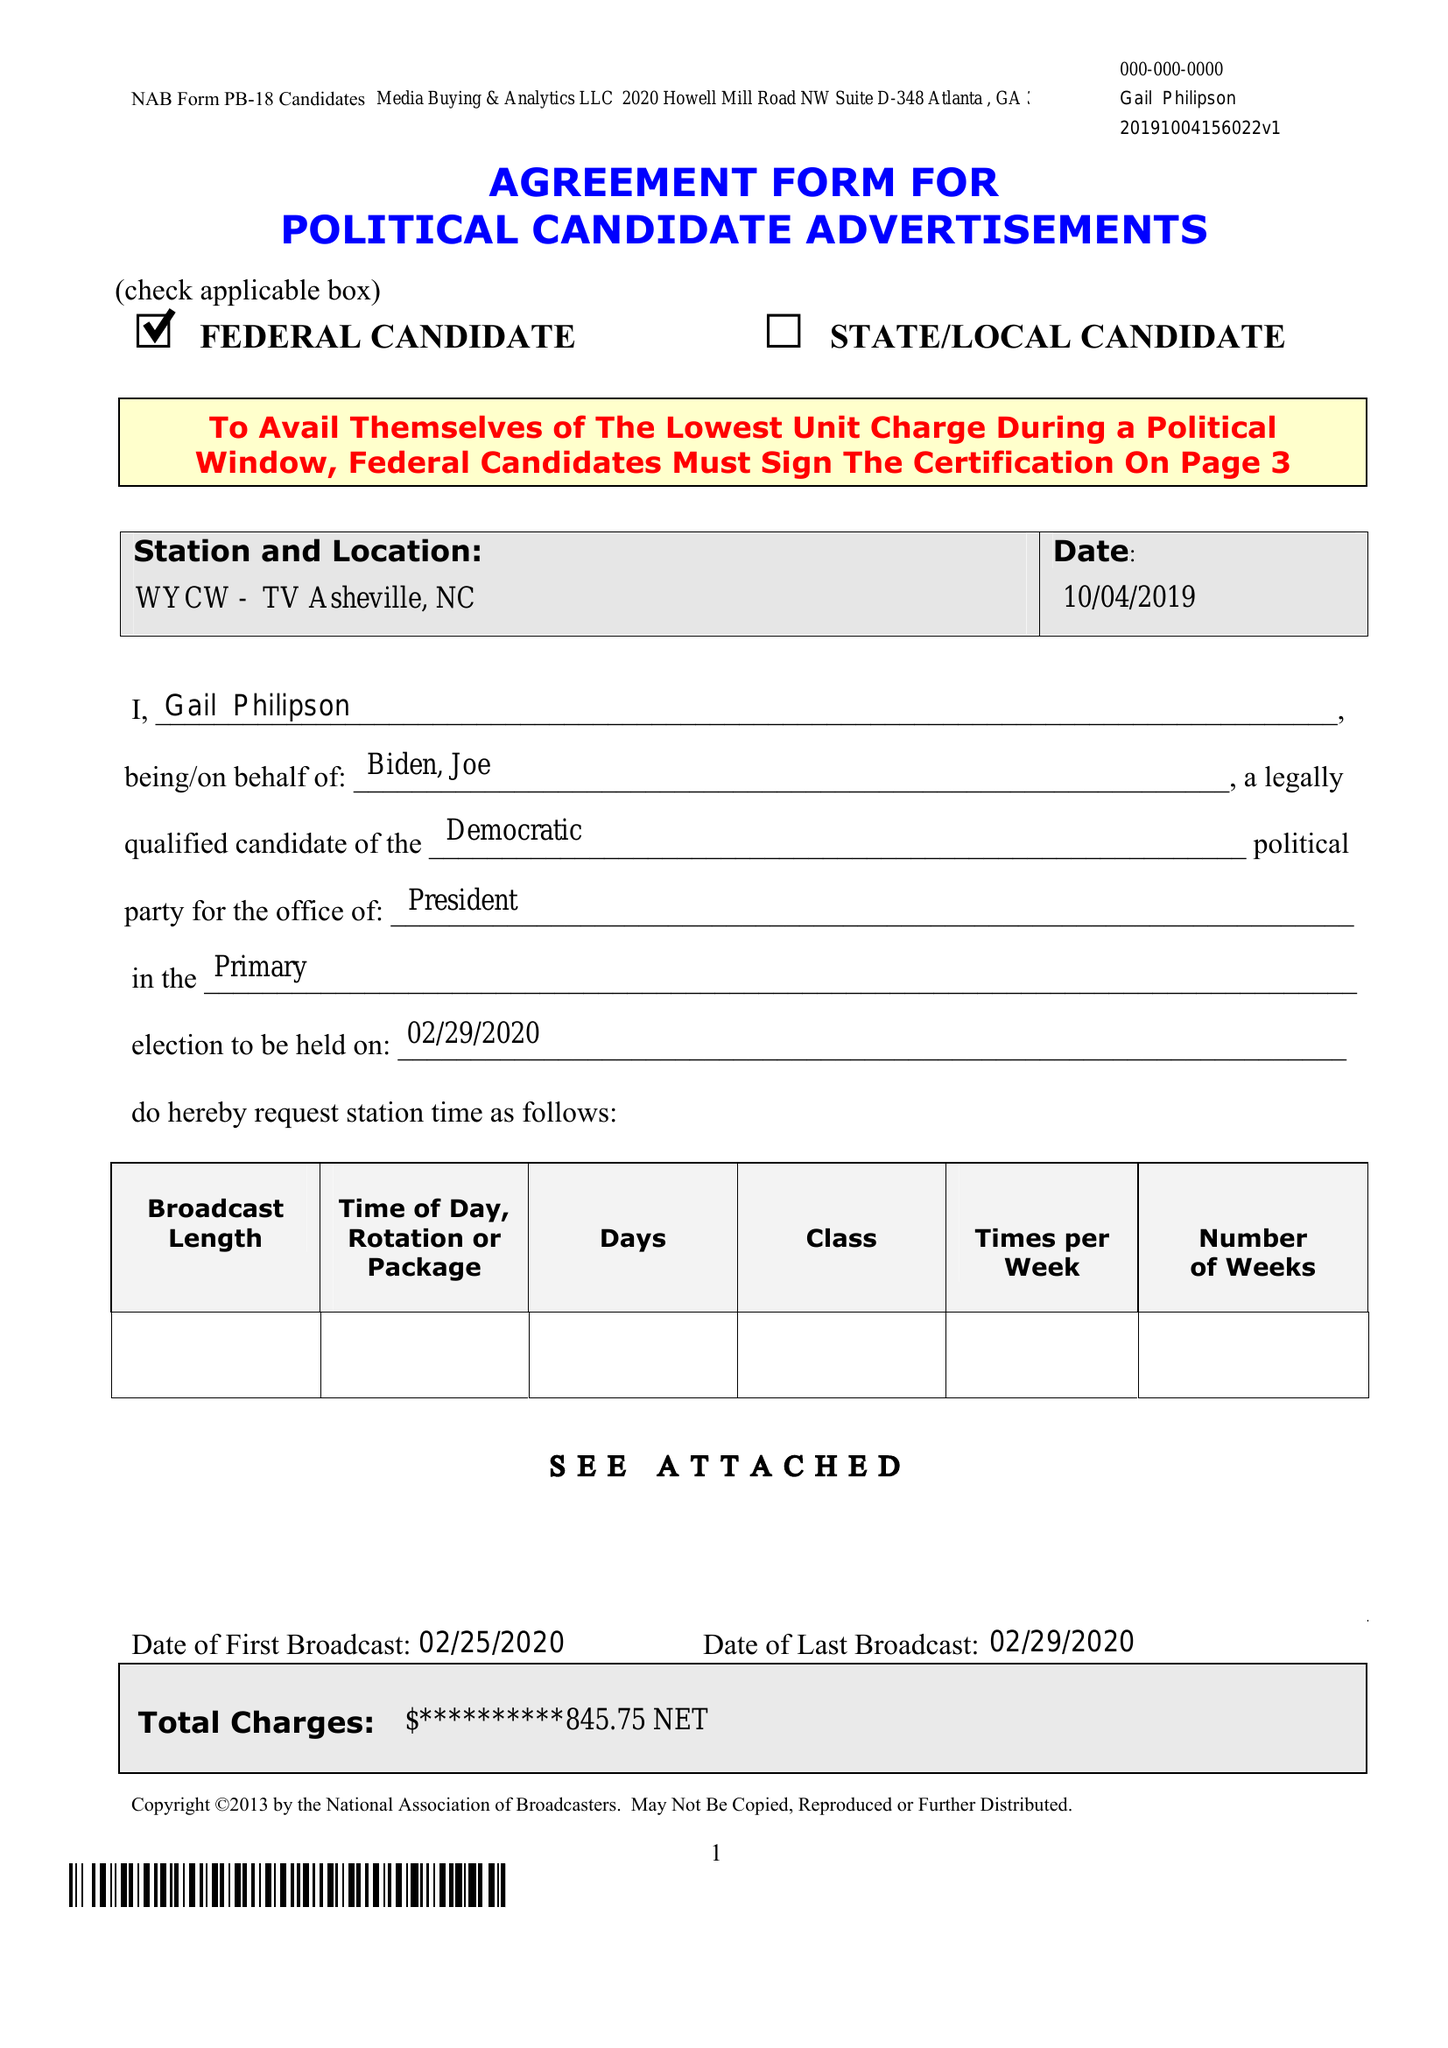What is the value for the flight_from?
Answer the question using a single word or phrase. 02/25/20 